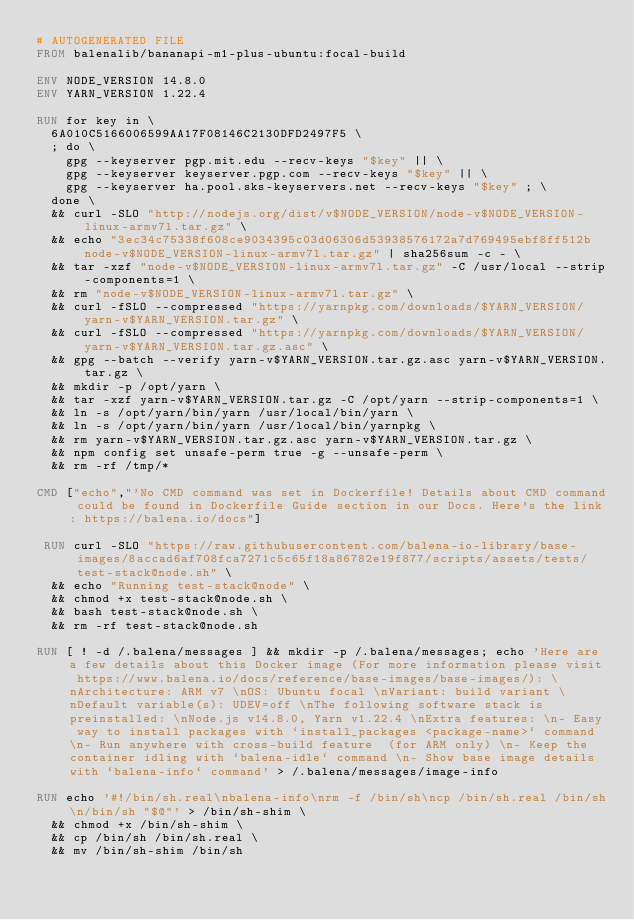<code> <loc_0><loc_0><loc_500><loc_500><_Dockerfile_># AUTOGENERATED FILE
FROM balenalib/bananapi-m1-plus-ubuntu:focal-build

ENV NODE_VERSION 14.8.0
ENV YARN_VERSION 1.22.4

RUN for key in \
	6A010C5166006599AA17F08146C2130DFD2497F5 \
	; do \
		gpg --keyserver pgp.mit.edu --recv-keys "$key" || \
		gpg --keyserver keyserver.pgp.com --recv-keys "$key" || \
		gpg --keyserver ha.pool.sks-keyservers.net --recv-keys "$key" ; \
	done \
	&& curl -SLO "http://nodejs.org/dist/v$NODE_VERSION/node-v$NODE_VERSION-linux-armv7l.tar.gz" \
	&& echo "3ec34c75338f608ce9034395c03d06306d53938576172a7d769495ebf8ff512b  node-v$NODE_VERSION-linux-armv7l.tar.gz" | sha256sum -c - \
	&& tar -xzf "node-v$NODE_VERSION-linux-armv7l.tar.gz" -C /usr/local --strip-components=1 \
	&& rm "node-v$NODE_VERSION-linux-armv7l.tar.gz" \
	&& curl -fSLO --compressed "https://yarnpkg.com/downloads/$YARN_VERSION/yarn-v$YARN_VERSION.tar.gz" \
	&& curl -fSLO --compressed "https://yarnpkg.com/downloads/$YARN_VERSION/yarn-v$YARN_VERSION.tar.gz.asc" \
	&& gpg --batch --verify yarn-v$YARN_VERSION.tar.gz.asc yarn-v$YARN_VERSION.tar.gz \
	&& mkdir -p /opt/yarn \
	&& tar -xzf yarn-v$YARN_VERSION.tar.gz -C /opt/yarn --strip-components=1 \
	&& ln -s /opt/yarn/bin/yarn /usr/local/bin/yarn \
	&& ln -s /opt/yarn/bin/yarn /usr/local/bin/yarnpkg \
	&& rm yarn-v$YARN_VERSION.tar.gz.asc yarn-v$YARN_VERSION.tar.gz \
	&& npm config set unsafe-perm true -g --unsafe-perm \
	&& rm -rf /tmp/*

CMD ["echo","'No CMD command was set in Dockerfile! Details about CMD command could be found in Dockerfile Guide section in our Docs. Here's the link: https://balena.io/docs"]

 RUN curl -SLO "https://raw.githubusercontent.com/balena-io-library/base-images/8accad6af708fca7271c5c65f18a86782e19f877/scripts/assets/tests/test-stack@node.sh" \
  && echo "Running test-stack@node" \
  && chmod +x test-stack@node.sh \
  && bash test-stack@node.sh \
  && rm -rf test-stack@node.sh 

RUN [ ! -d /.balena/messages ] && mkdir -p /.balena/messages; echo 'Here are a few details about this Docker image (For more information please visit https://www.balena.io/docs/reference/base-images/base-images/): \nArchitecture: ARM v7 \nOS: Ubuntu focal \nVariant: build variant \nDefault variable(s): UDEV=off \nThe following software stack is preinstalled: \nNode.js v14.8.0, Yarn v1.22.4 \nExtra features: \n- Easy way to install packages with `install_packages <package-name>` command \n- Run anywhere with cross-build feature  (for ARM only) \n- Keep the container idling with `balena-idle` command \n- Show base image details with `balena-info` command' > /.balena/messages/image-info

RUN echo '#!/bin/sh.real\nbalena-info\nrm -f /bin/sh\ncp /bin/sh.real /bin/sh\n/bin/sh "$@"' > /bin/sh-shim \
	&& chmod +x /bin/sh-shim \
	&& cp /bin/sh /bin/sh.real \
	&& mv /bin/sh-shim /bin/sh</code> 